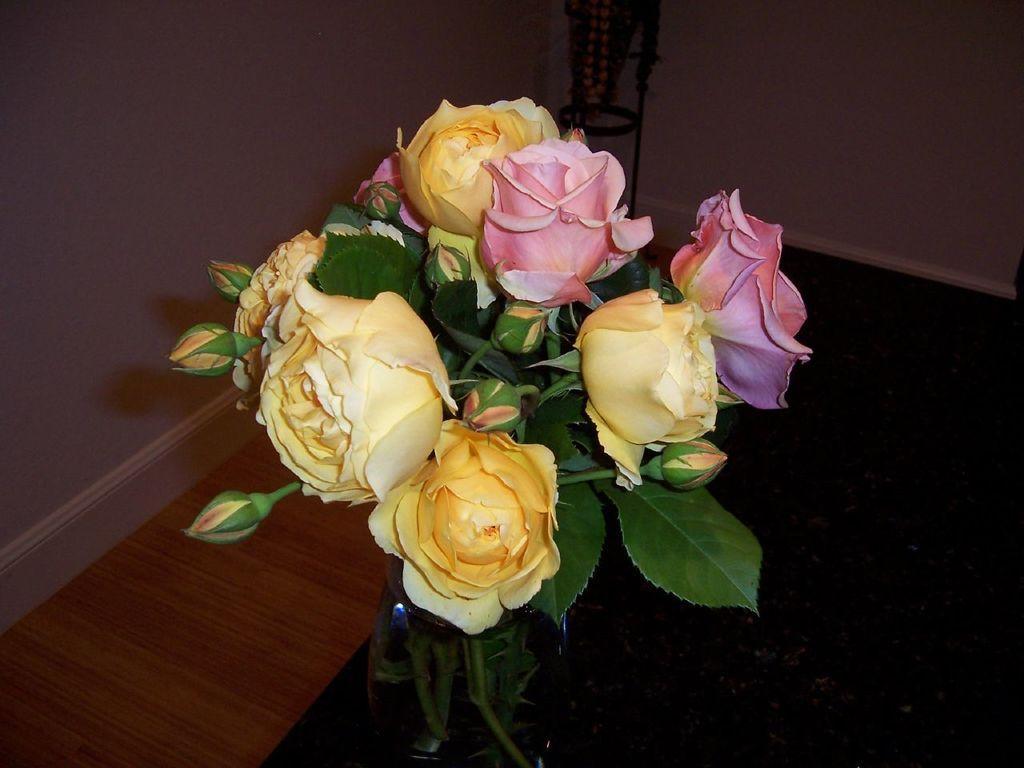Describe this image in one or two sentences. In this image we can see a flower vase with flowers, buds and leaves on the table, and there is a stand near the wall. 